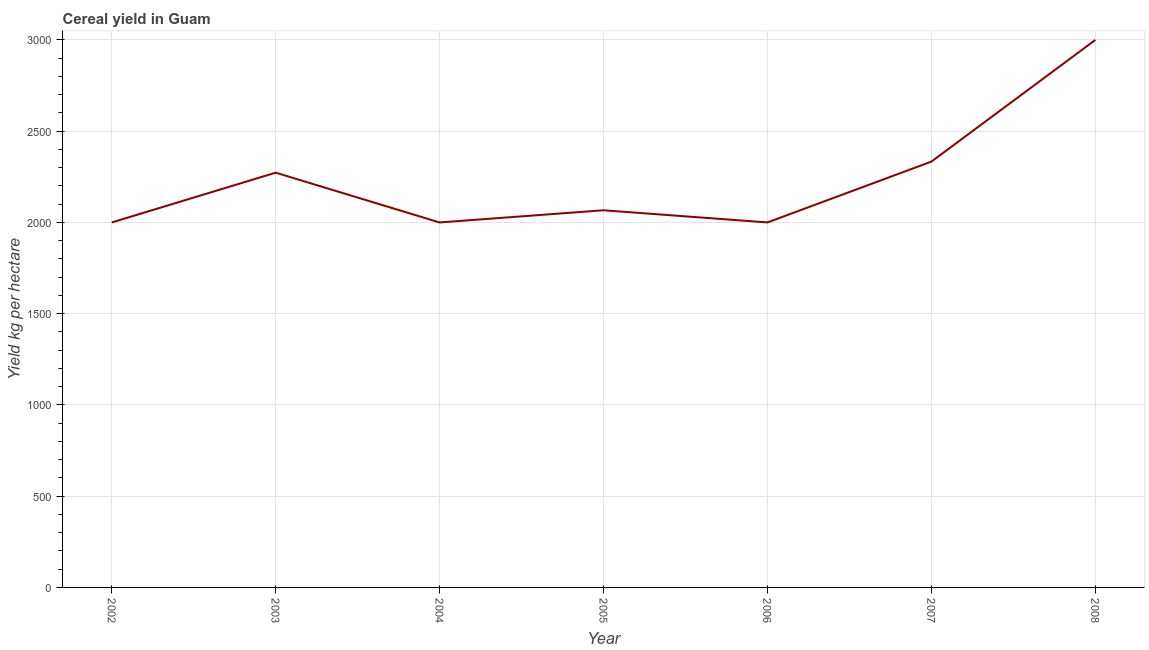What is the cereal yield in 2008?
Make the answer very short. 3000. Across all years, what is the maximum cereal yield?
Provide a succinct answer. 3000. Across all years, what is the minimum cereal yield?
Your response must be concise. 2000. What is the sum of the cereal yield?
Make the answer very short. 1.57e+04. What is the difference between the cereal yield in 2002 and 2003?
Make the answer very short. -272.73. What is the average cereal yield per year?
Offer a terse response. 2238.96. What is the median cereal yield?
Keep it short and to the point. 2066.67. Do a majority of the years between 2002 and 2008 (inclusive) have cereal yield greater than 1900 kg per hectare?
Ensure brevity in your answer.  Yes. What is the ratio of the cereal yield in 2007 to that in 2008?
Offer a terse response. 0.78. Is the cereal yield in 2007 less than that in 2008?
Your answer should be compact. Yes. Is the difference between the cereal yield in 2003 and 2006 greater than the difference between any two years?
Make the answer very short. No. What is the difference between the highest and the second highest cereal yield?
Your answer should be very brief. 666.67. Is the sum of the cereal yield in 2004 and 2006 greater than the maximum cereal yield across all years?
Your answer should be very brief. Yes. How many lines are there?
Your response must be concise. 1. How many years are there in the graph?
Provide a short and direct response. 7. Are the values on the major ticks of Y-axis written in scientific E-notation?
Make the answer very short. No. What is the title of the graph?
Your answer should be very brief. Cereal yield in Guam. What is the label or title of the Y-axis?
Give a very brief answer. Yield kg per hectare. What is the Yield kg per hectare in 2002?
Your answer should be compact. 2000. What is the Yield kg per hectare in 2003?
Your answer should be very brief. 2272.73. What is the Yield kg per hectare in 2005?
Provide a short and direct response. 2066.67. What is the Yield kg per hectare in 2006?
Make the answer very short. 2000. What is the Yield kg per hectare of 2007?
Provide a succinct answer. 2333.33. What is the Yield kg per hectare of 2008?
Provide a short and direct response. 3000. What is the difference between the Yield kg per hectare in 2002 and 2003?
Your answer should be very brief. -272.73. What is the difference between the Yield kg per hectare in 2002 and 2004?
Make the answer very short. 0. What is the difference between the Yield kg per hectare in 2002 and 2005?
Provide a short and direct response. -66.67. What is the difference between the Yield kg per hectare in 2002 and 2006?
Provide a succinct answer. 0. What is the difference between the Yield kg per hectare in 2002 and 2007?
Your answer should be very brief. -333.33. What is the difference between the Yield kg per hectare in 2002 and 2008?
Your answer should be compact. -1000. What is the difference between the Yield kg per hectare in 2003 and 2004?
Offer a very short reply. 272.73. What is the difference between the Yield kg per hectare in 2003 and 2005?
Give a very brief answer. 206.06. What is the difference between the Yield kg per hectare in 2003 and 2006?
Make the answer very short. 272.73. What is the difference between the Yield kg per hectare in 2003 and 2007?
Your response must be concise. -60.61. What is the difference between the Yield kg per hectare in 2003 and 2008?
Your answer should be very brief. -727.27. What is the difference between the Yield kg per hectare in 2004 and 2005?
Provide a short and direct response. -66.67. What is the difference between the Yield kg per hectare in 2004 and 2006?
Your answer should be compact. 0. What is the difference between the Yield kg per hectare in 2004 and 2007?
Provide a short and direct response. -333.33. What is the difference between the Yield kg per hectare in 2004 and 2008?
Offer a very short reply. -1000. What is the difference between the Yield kg per hectare in 2005 and 2006?
Your answer should be very brief. 66.67. What is the difference between the Yield kg per hectare in 2005 and 2007?
Your answer should be very brief. -266.67. What is the difference between the Yield kg per hectare in 2005 and 2008?
Give a very brief answer. -933.33. What is the difference between the Yield kg per hectare in 2006 and 2007?
Make the answer very short. -333.33. What is the difference between the Yield kg per hectare in 2006 and 2008?
Offer a very short reply. -1000. What is the difference between the Yield kg per hectare in 2007 and 2008?
Offer a terse response. -666.67. What is the ratio of the Yield kg per hectare in 2002 to that in 2003?
Provide a short and direct response. 0.88. What is the ratio of the Yield kg per hectare in 2002 to that in 2006?
Give a very brief answer. 1. What is the ratio of the Yield kg per hectare in 2002 to that in 2007?
Keep it short and to the point. 0.86. What is the ratio of the Yield kg per hectare in 2002 to that in 2008?
Offer a terse response. 0.67. What is the ratio of the Yield kg per hectare in 2003 to that in 2004?
Offer a terse response. 1.14. What is the ratio of the Yield kg per hectare in 2003 to that in 2006?
Provide a short and direct response. 1.14. What is the ratio of the Yield kg per hectare in 2003 to that in 2008?
Offer a very short reply. 0.76. What is the ratio of the Yield kg per hectare in 2004 to that in 2005?
Offer a very short reply. 0.97. What is the ratio of the Yield kg per hectare in 2004 to that in 2007?
Provide a short and direct response. 0.86. What is the ratio of the Yield kg per hectare in 2004 to that in 2008?
Your response must be concise. 0.67. What is the ratio of the Yield kg per hectare in 2005 to that in 2006?
Make the answer very short. 1.03. What is the ratio of the Yield kg per hectare in 2005 to that in 2007?
Offer a very short reply. 0.89. What is the ratio of the Yield kg per hectare in 2005 to that in 2008?
Your response must be concise. 0.69. What is the ratio of the Yield kg per hectare in 2006 to that in 2007?
Your answer should be compact. 0.86. What is the ratio of the Yield kg per hectare in 2006 to that in 2008?
Keep it short and to the point. 0.67. What is the ratio of the Yield kg per hectare in 2007 to that in 2008?
Give a very brief answer. 0.78. 